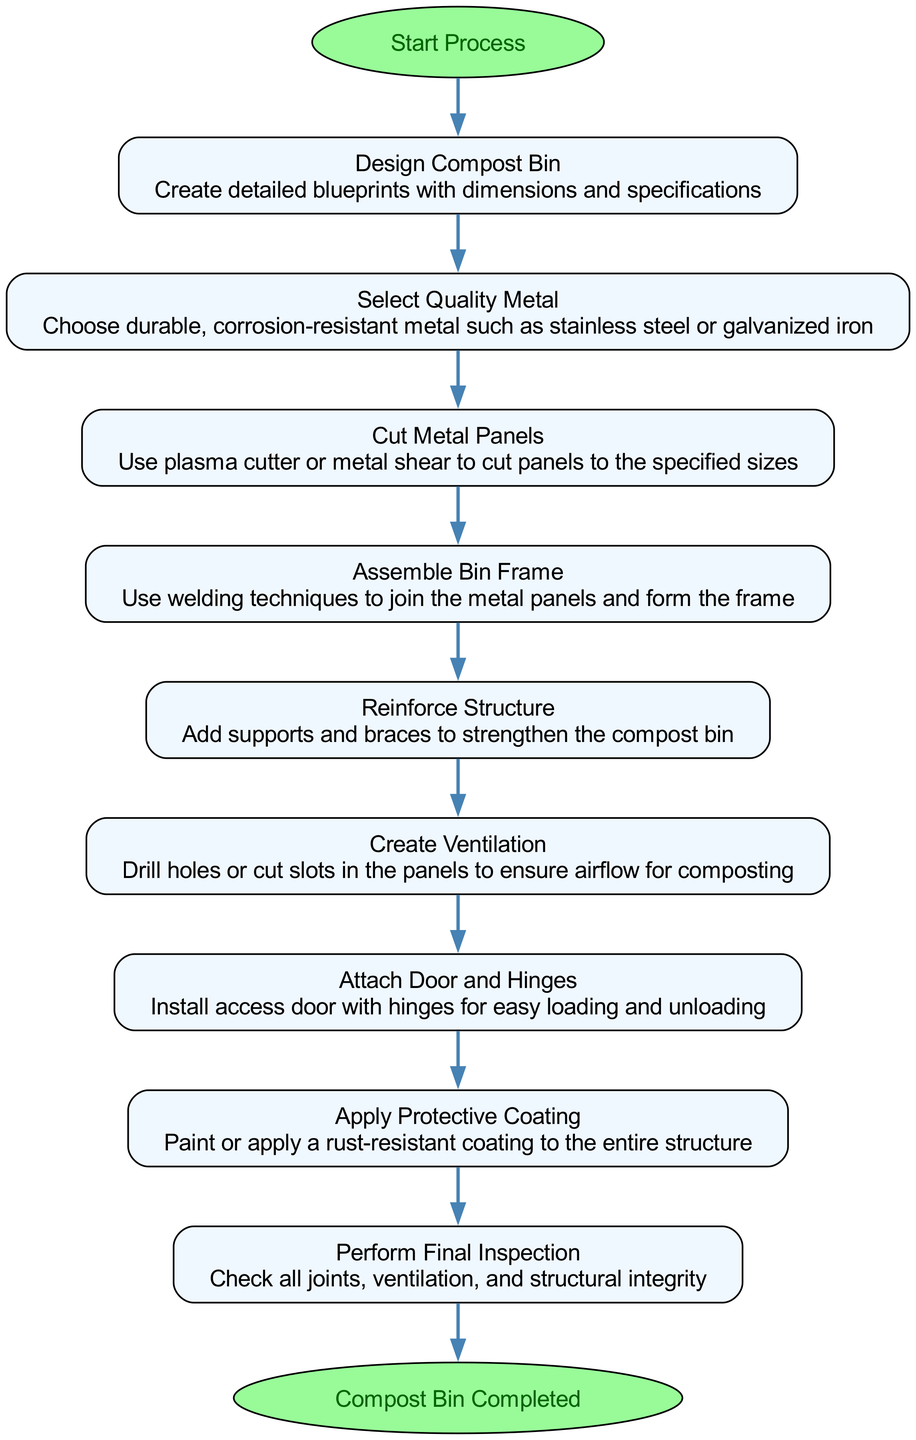What is the first step in the process? The first step is indicated by the start node, which leads to the 'Design Compost Bin' process. Therefore, the answer is ‘Design Compost Bin’.
Answer: Design Compost Bin How many processes are included in the flow chart? The processes are listed from 'Design Compost Bin' to 'Perform Final Inspection', totaling 9 processes. This means we count each node with the process type.
Answer: 9 What is the last action before completing the compost bin? The last action taken, before reaching completion, is 'Perform Final Inspection'. This is the node right before the end node in the flow sequence.
Answer: Perform Final Inspection Which stage involves selecting the metal type? The stage that involves metal selection is ‘Select Quality Metal’ which directly follows the design phase. It comes after 'Design Compost Bin'.
Answer: Select Quality Metal What type of metal should be chosen for durability? The flow chart specifies to choose durable metal such as stainless steel or galvanized iron as a requirement in the 'Select Quality Metal' step.
Answer: Stainless steel or galvanized iron Which step confirms the structural integrity of the compost bin? The step that confirms structural integrity is 'Perform Final Inspection'. This step is essential to ensure all previous processes were executed correctly.
Answer: Perform Final Inspection What is created to ensure airflow for composting? The 'Create Ventilation' step is specifically designed to drill holes or cut slots to ensure airflow in the compost bin.
Answer: Create Ventilation How are the metal panels connected during assembly? The frames are assembled using welding techniques in the 'Assemble Bin Frame' step, which is essential for joining the metal panels.
Answer: Welding techniques What process follows the application of a protective coating? After applying the protective coating, the next process is 'Perform Final Inspection', ensuring everything is correctly set before completion.
Answer: Perform Final Inspection 